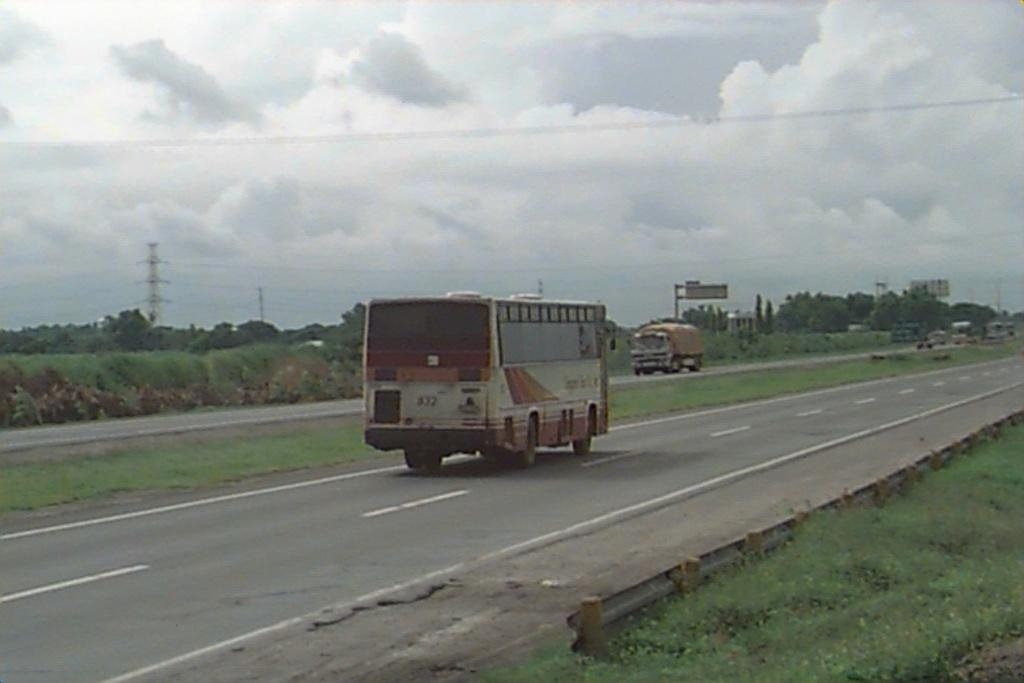What can be seen on the road in the image? There are vehicles on the road in the image. What type of vegetation is present in the image? There are trees and grass in the image. What structures can be seen in the image? There are electrical poles and hoardings in the image. What else can be seen in the image? There are wires in the image. What is visible in the background of the image? The sky with clouds is visible in the background of the image. What is the purpose of the father's dress in the image? There is no father or dress present in the image. What type of dress is the father wearing in the image? There is no father or dress present in the image. 